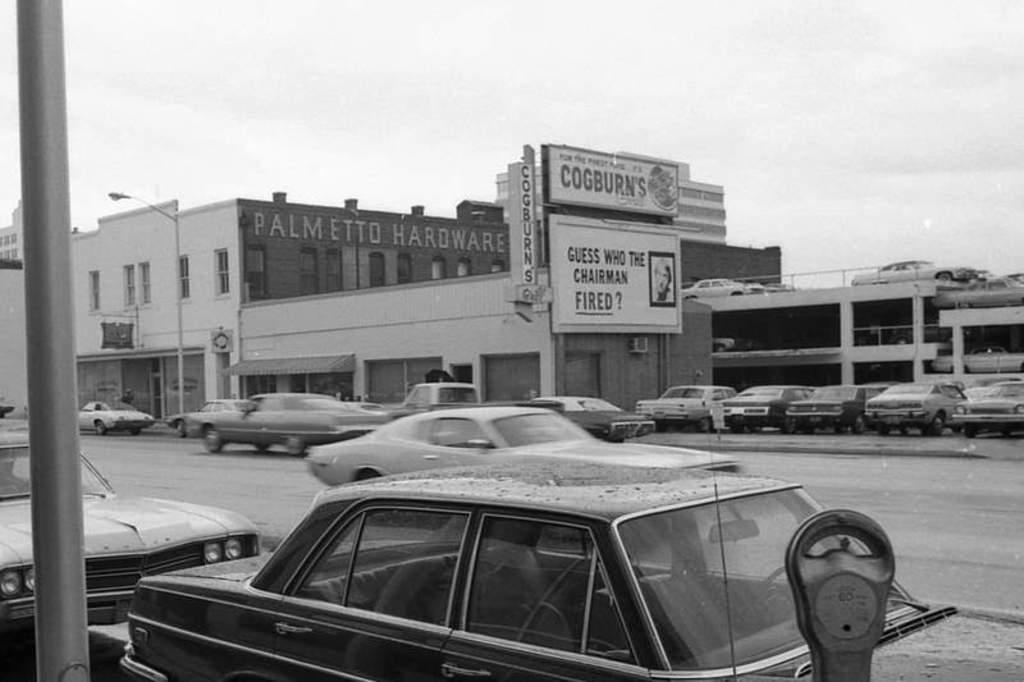Can you describe this image briefly? In this picture I can observe some cars moving on the road. On the right side some of the cars are parked in the parking lot. In the background there is a building and sky. 